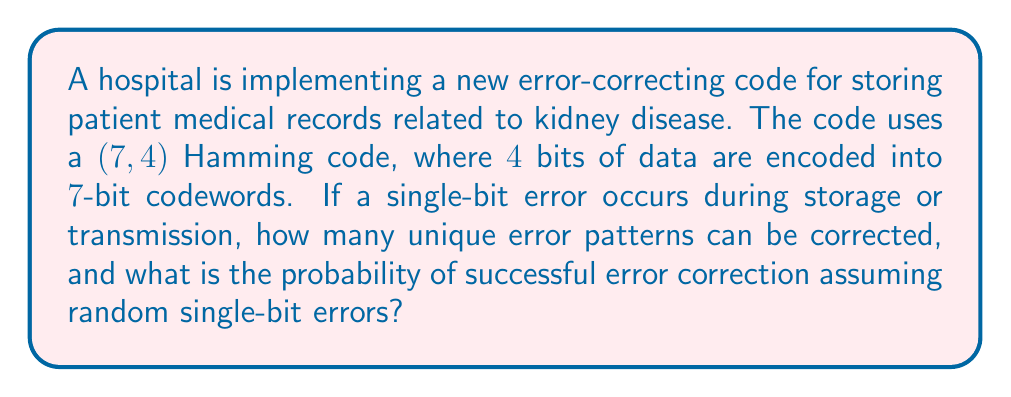What is the answer to this math problem? To solve this problem, let's break it down into steps:

1. Understanding the Hamming code:
   The (7,4) Hamming code encodes 4 bits of data into 7-bit codewords. This means there are 3 parity bits added for error correction.

2. Calculating the number of unique error patterns:
   In a 7-bit codeword, a single-bit error can occur in any of the 7 positions. Therefore, the number of unique error patterns is simply 7.

3. Calculating the probability of successful error correction:
   The Hamming code can correct all single-bit errors. To find the probability of successful correction, we need to consider:

   a) The total number of possible error patterns:
      With 7 bits, there are $2^7 = 128$ possible patterns (including the case of no error).

   b) The number of correctable error patterns:
      There are 7 single-bit error patterns plus 1 no-error pattern, totaling 8 patterns that can be handled correctly.

   c) The probability of successful correction:
      Assuming all error patterns are equally likely, the probability is:

      $$P(\text{successful correction}) = \frac{\text{Number of correctable patterns}}{\text{Total number of possible patterns}} = \frac{8}{128} = \frac{1}{16} = 0.0625$$

This means that if errors occur randomly (including the possibility of no error), the probability of successful error correction is 6.25%.
Answer: Number of unique error patterns that can be corrected: 7
Probability of successful error correction: $\frac{1}{16}$ or 0.0625 (6.25%) 